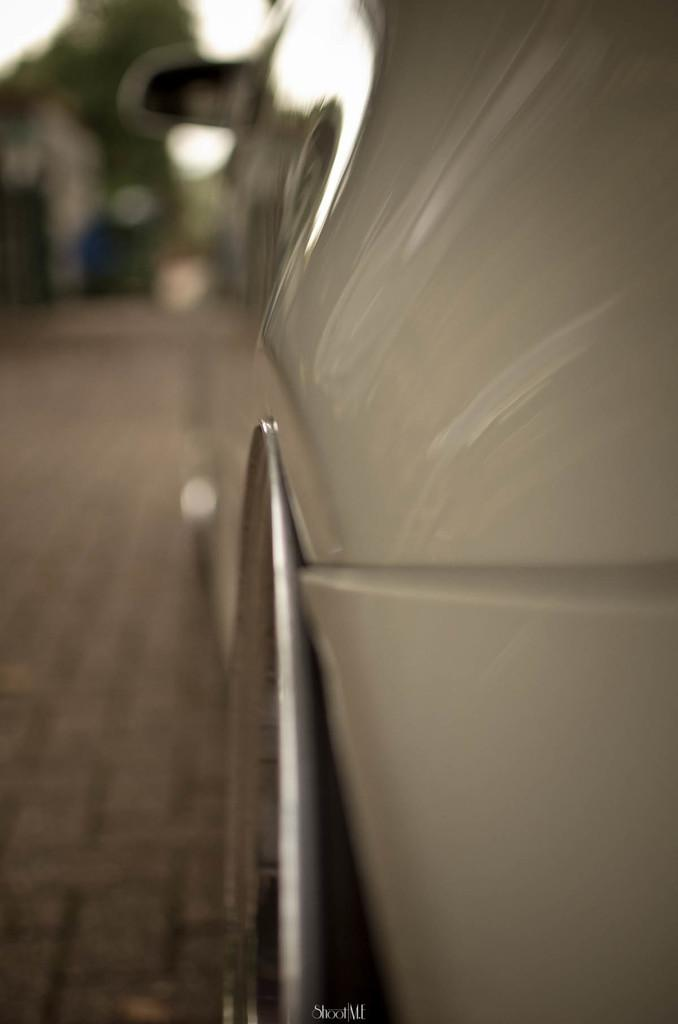What is the main subject of the image? There is a vehicle in the image. How is the vehicle positioned in the image? The vehicle is shown from the side. What can be observed about the background of the image? The background of the image is blurred. Is there any additional information or markings on the image? Yes, there is a watermark on the image. Can you describe the kitten playing with a rose in the image? There is no kitten or rose present in the image; it features a vehicle shown from the side with a blurred background and a watermark. 